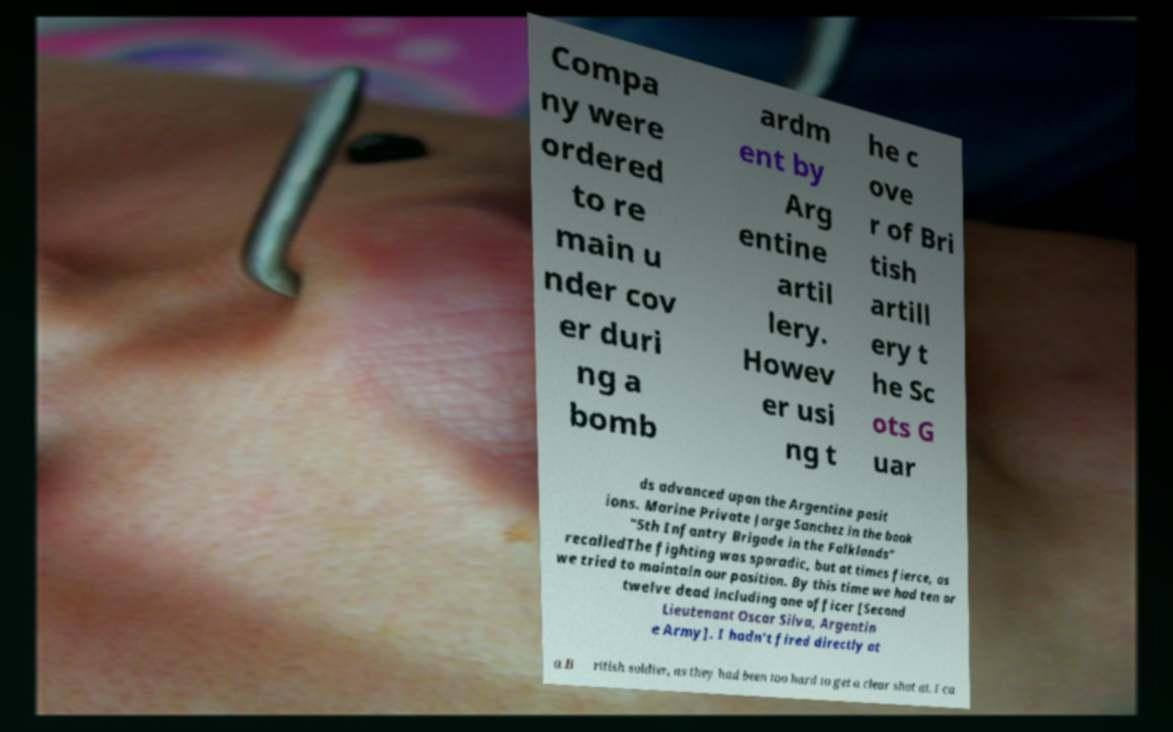Can you accurately transcribe the text from the provided image for me? Compa ny were ordered to re main u nder cov er duri ng a bomb ardm ent by Arg entine artil lery. Howev er usi ng t he c ove r of Bri tish artill ery t he Sc ots G uar ds advanced upon the Argentine posit ions. Marine Private Jorge Sanchez in the book "5th Infantry Brigade in the Falklands" recalledThe fighting was sporadic, but at times fierce, as we tried to maintain our position. By this time we had ten or twelve dead including one officer [Second Lieutenant Oscar Silva, Argentin e Army]. I hadn't fired directly at a B ritish soldier, as they had been too hard to get a clear shot at. I ca 